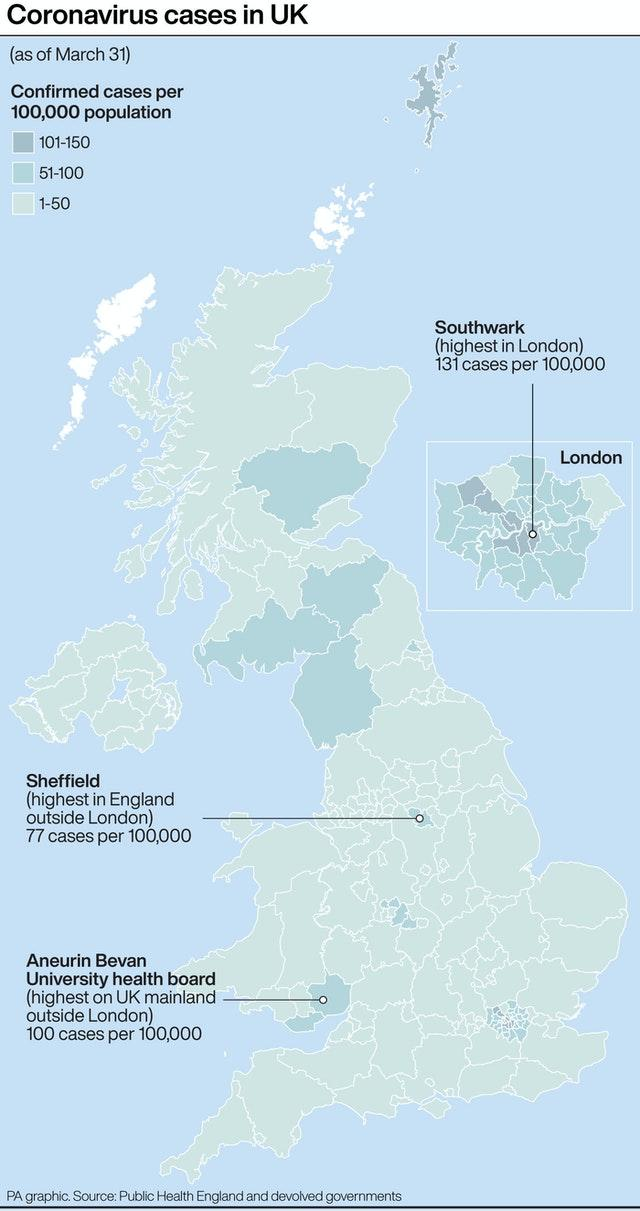Specify some key components in this picture. In Southwark, the number of falls that occur falls within the range of 101-150. The majority of COVID-19 cases in the UK fall within the range of 1 to 50, according to recent data. The place with the highest number of COVID-19 cases outside of London is [insert location]. There have been [insert number] cases reported there. 